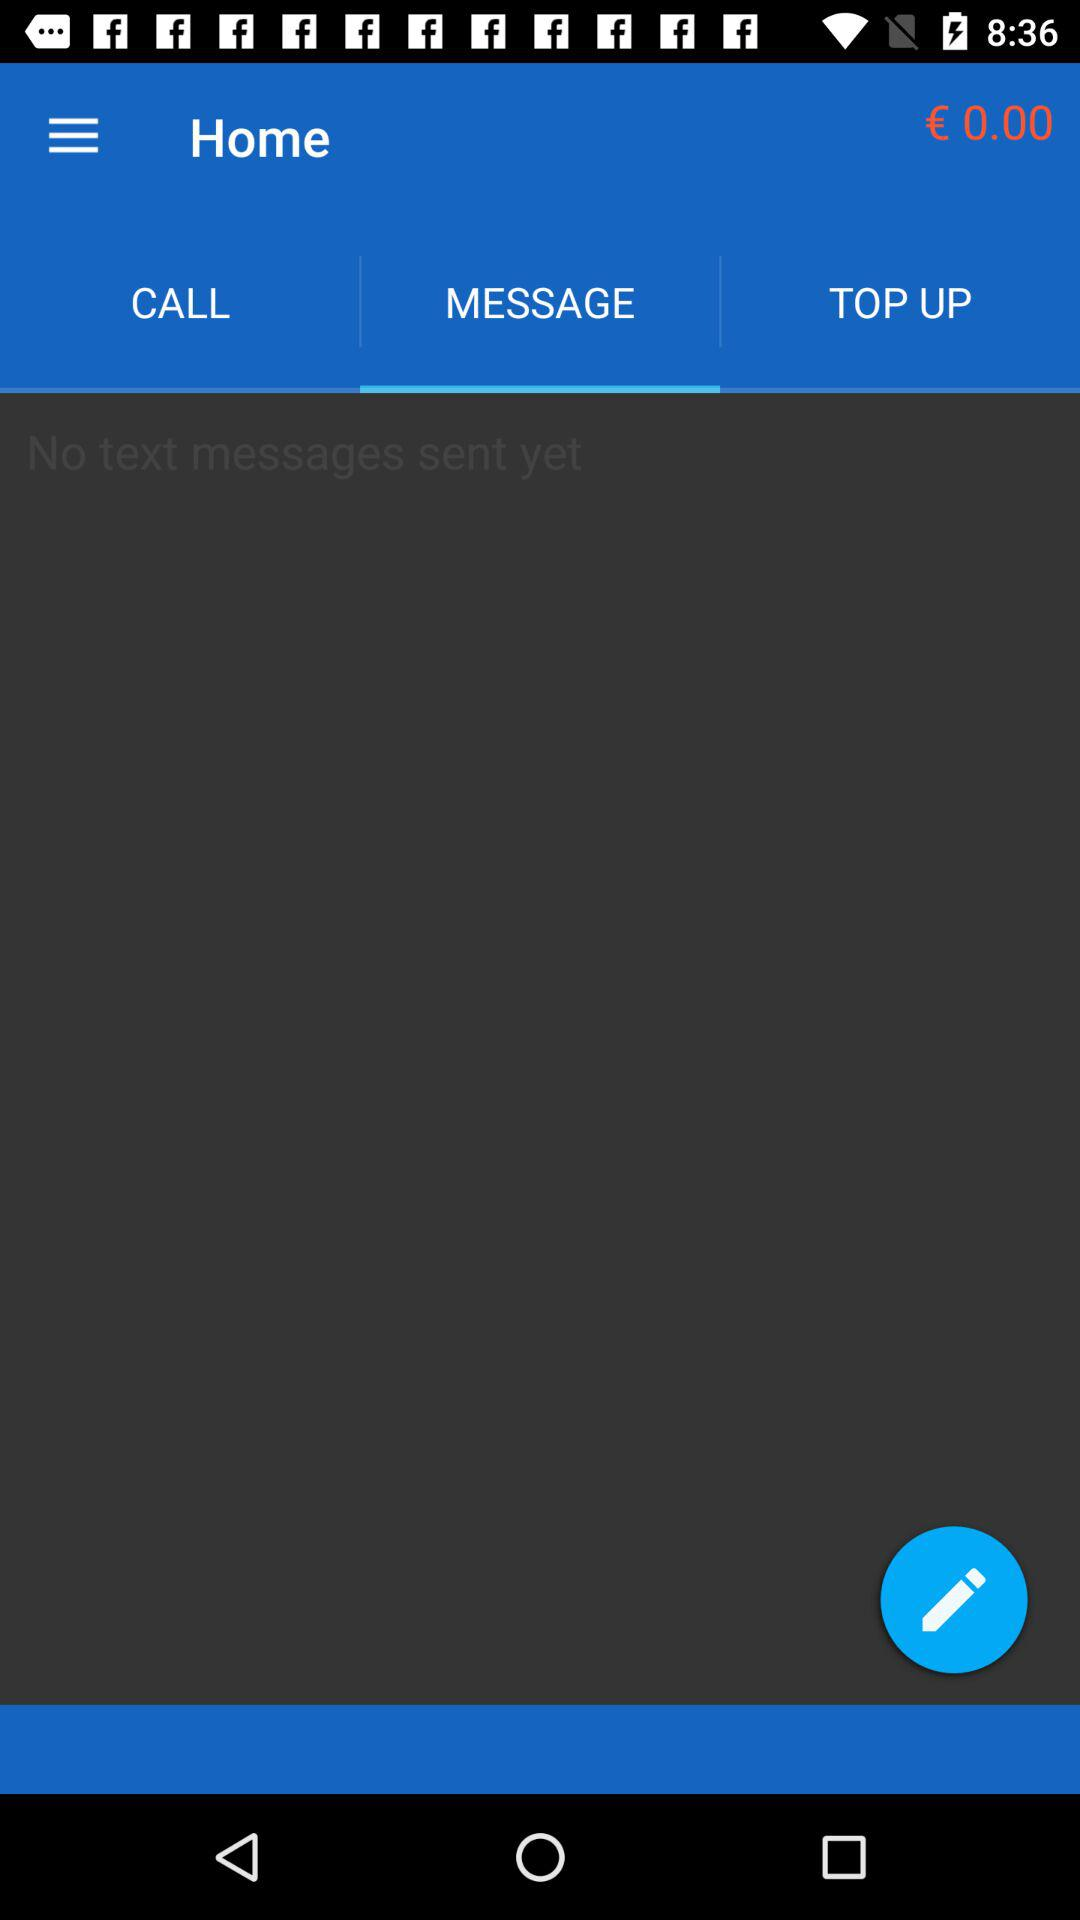How many text messages have I sent?
Answer the question using a single word or phrase. 0 